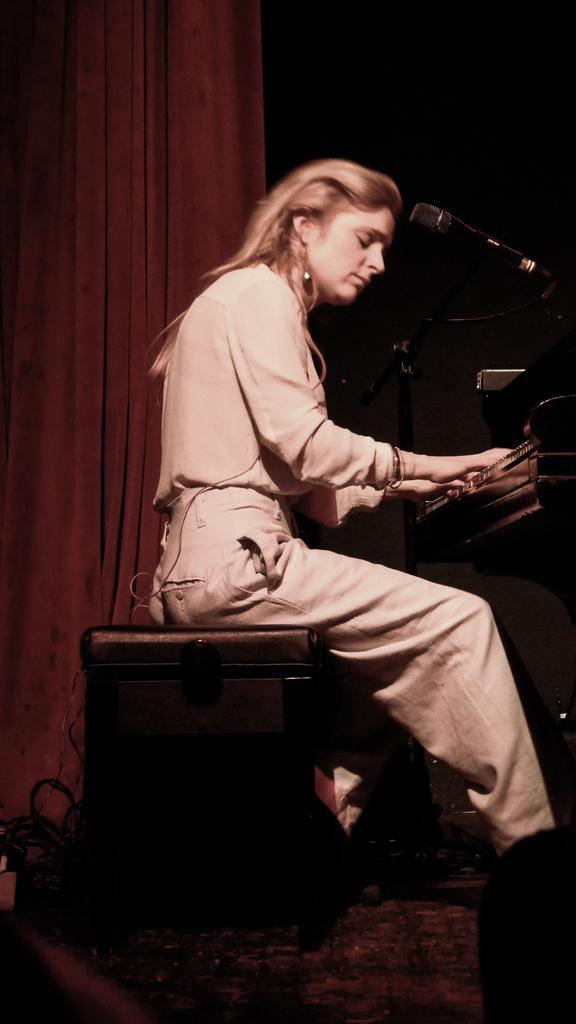Who is the main subject in the image? There is a woman in the image. What is the woman doing in the image? The woman is sitting on a stool and playing a piano. What other objects can be seen in the image? There is a microphone with a microphone stand and a curtain hanging in the background. How is the curtain hung in the background? The curtain is hung using a hanger. What type of flag is hanging from the branch in the image? There is no flag or branch present in the image. 